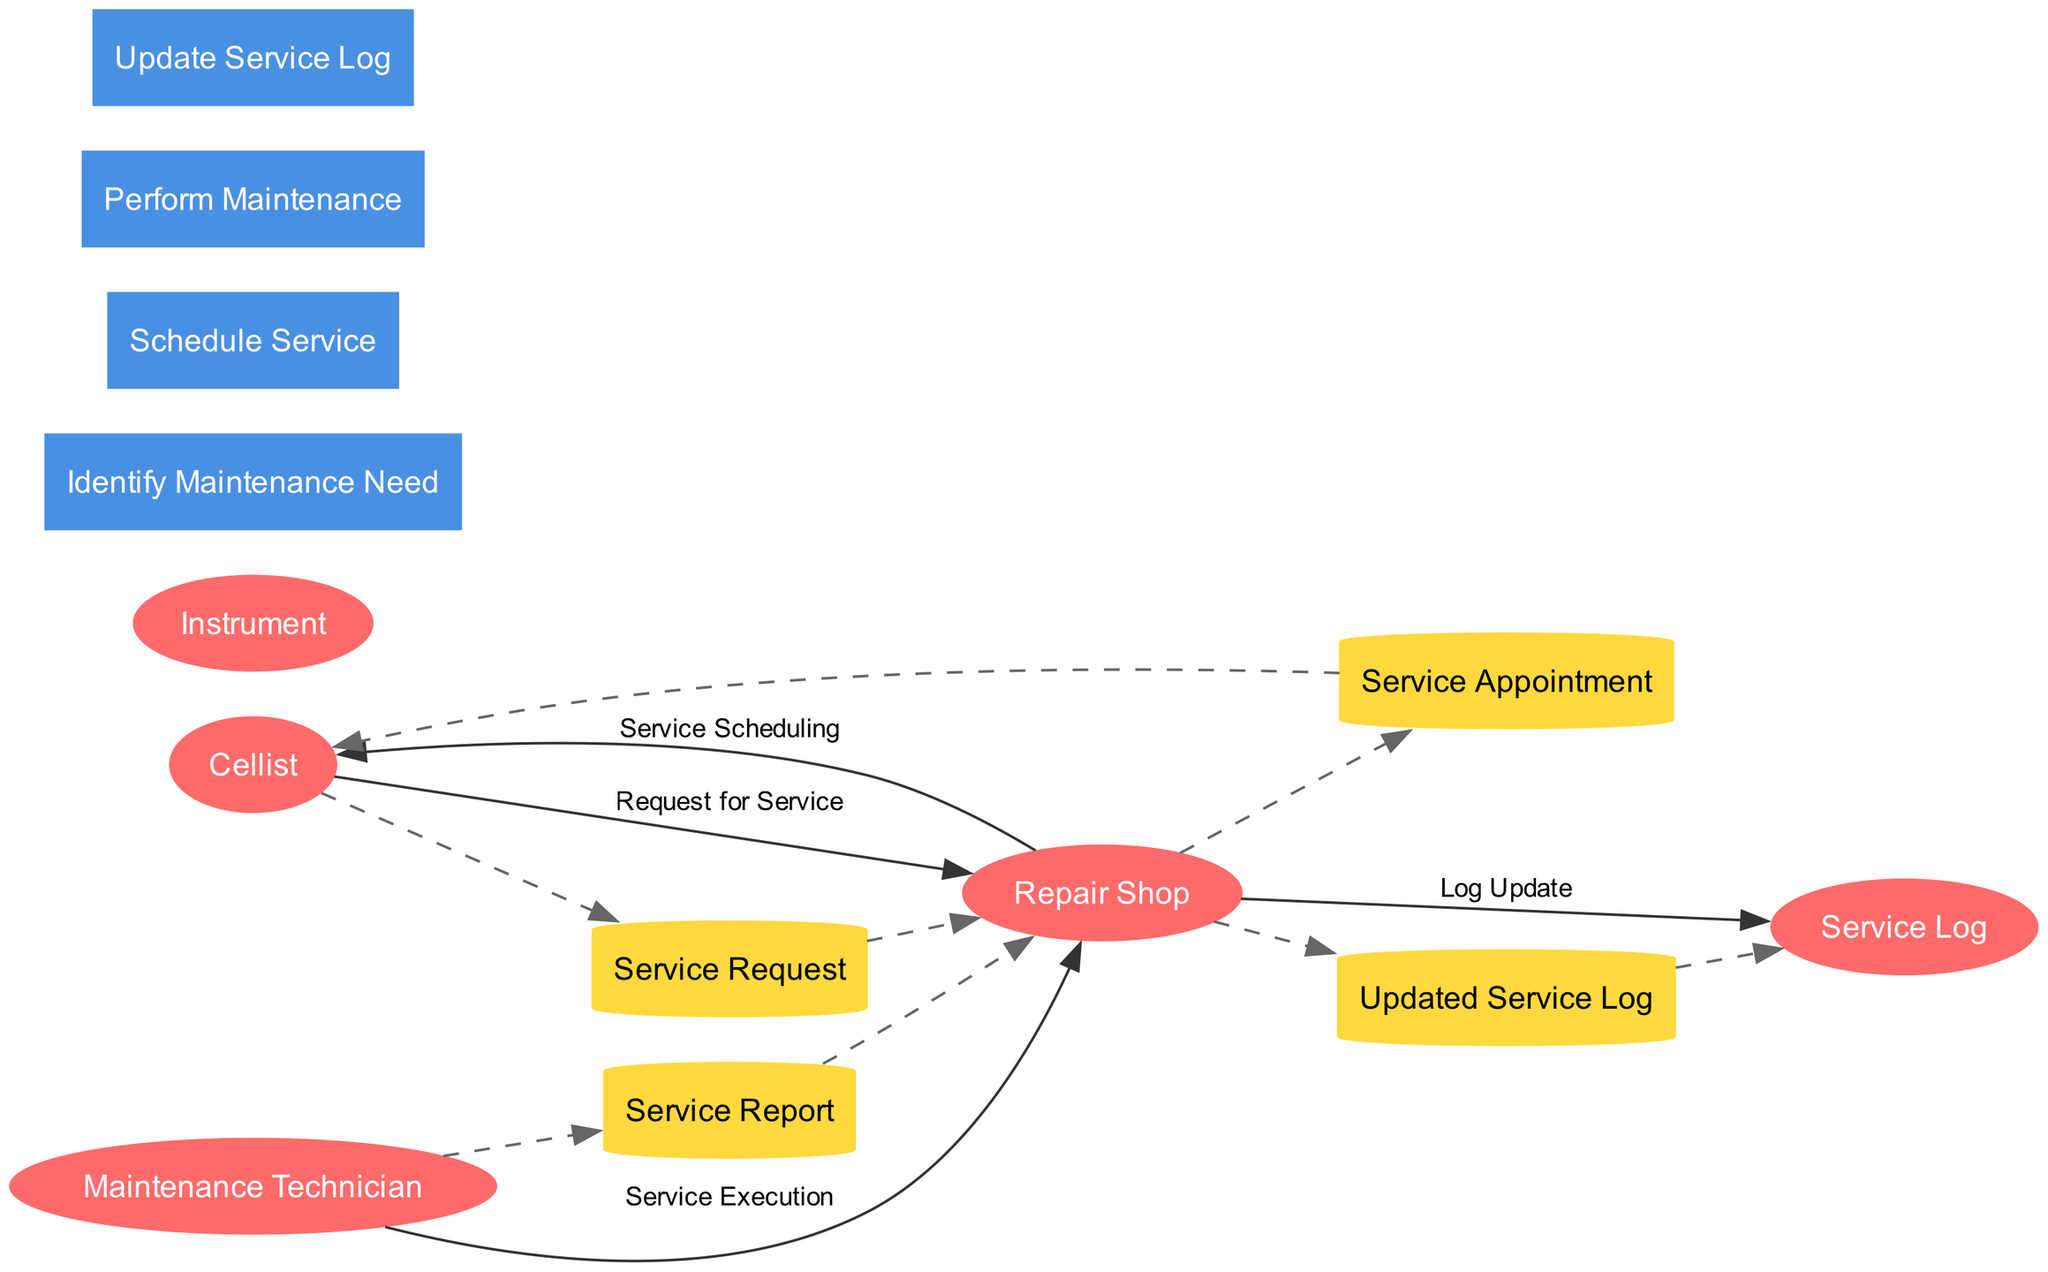What is the first process in the diagram? The first process shown in the diagram is "Identify Maintenance Need," which is responsible for taking the Instrument as input and generating a Service Request as output.
Answer: Identify Maintenance Need Who initiates the service request? The service request is initiated by the Cellist, as indicated by the flow connecting the Cellist to the Repair Shop with a label of "Request for Service."
Answer: Cellist What is stored in the Service Report data store? The Service Report data store consists of maintenance details and technician notes, which are recorded as part of the Service Report process.
Answer: Maintenance Details, Technician Notes How many data stores are present in the diagram? There are four data stores in the diagram: Service Request, Service Appointment, Service Report, and Updated Service Log. By counting these, we observe that they total four.
Answer: Four What is the output of the "Schedule Service" process? The output of the "Schedule Service" process is "Service Appointment," which is generated after processing the Service Request.
Answer: Service Appointment Who performs the maintenance? The maintenance is performed by the Maintenance Technician, as indicated by the input and output flows associated with the "Perform Maintenance" process.
Answer: Maintenance Technician What type of diagram is depicted here? The diagram represents a Data Flow Diagram, which outlines the flow of information between entities, processes, and data stores in the context of Instrument Maintenance and Repair Workflow.
Answer: Data Flow Diagram What connects the Maintenance Technician and the Repair Shop? The connection between the Maintenance Technician and the Repair Shop is established through the "Service Execution" flow, which shows the Service Report being sent after maintenance is performed.
Answer: Service Report 